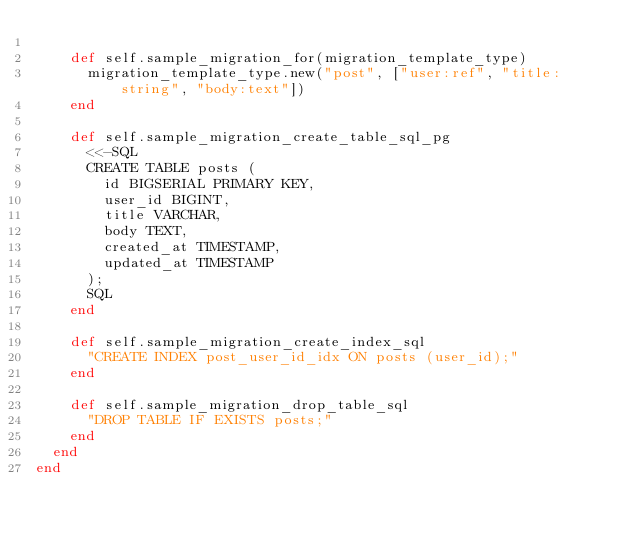<code> <loc_0><loc_0><loc_500><loc_500><_Crystal_>
    def self.sample_migration_for(migration_template_type)
      migration_template_type.new("post", ["user:ref", "title:string", "body:text"])
    end

    def self.sample_migration_create_table_sql_pg
      <<-SQL
      CREATE TABLE posts (
        id BIGSERIAL PRIMARY KEY,
        user_id BIGINT,
        title VARCHAR,
        body TEXT,
        created_at TIMESTAMP,
        updated_at TIMESTAMP
      );
      SQL
    end

    def self.sample_migration_create_index_sql
      "CREATE INDEX post_user_id_idx ON posts (user_id);"
    end

    def self.sample_migration_drop_table_sql
      "DROP TABLE IF EXISTS posts;"
    end
  end
end
</code> 